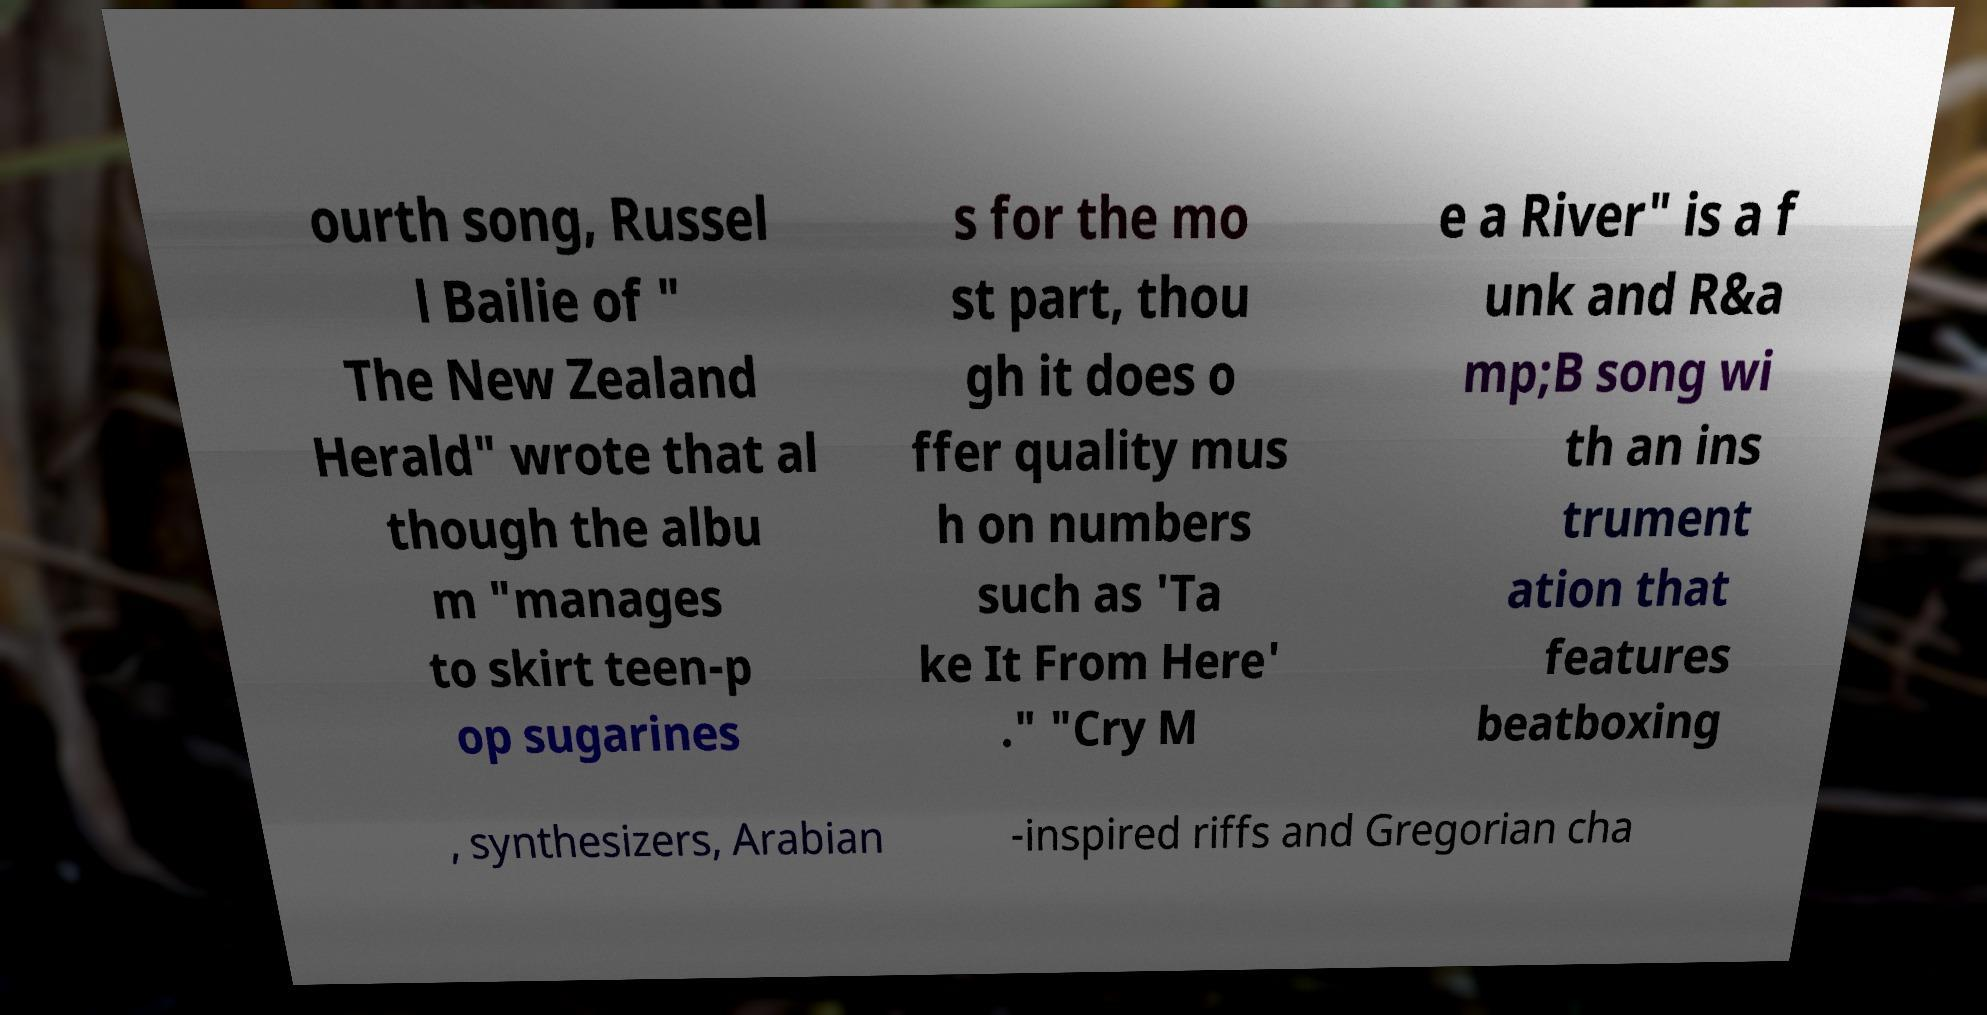Could you assist in decoding the text presented in this image and type it out clearly? ourth song, Russel l Bailie of " The New Zealand Herald" wrote that al though the albu m "manages to skirt teen-p op sugarines s for the mo st part, thou gh it does o ffer quality mus h on numbers such as 'Ta ke It From Here' ." "Cry M e a River" is a f unk and R&a mp;B song wi th an ins trument ation that features beatboxing , synthesizers, Arabian -inspired riffs and Gregorian cha 